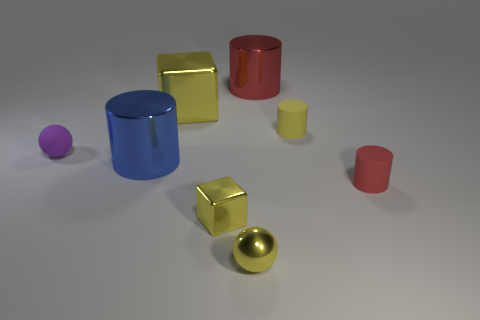Can you count the number of objects in different colors? Certainly! In the image, there are seven objects in total, featuring a range of colors: one purple, two blue, one gold, one red, one yellow, and one pink. Which objects appear to have a reflective surface? All the objects in the image have reflective surfaces to some extent. However, the gold and yellow objects exhibit particularly high reflectivity, giving them a shiny, metallic appearance. 